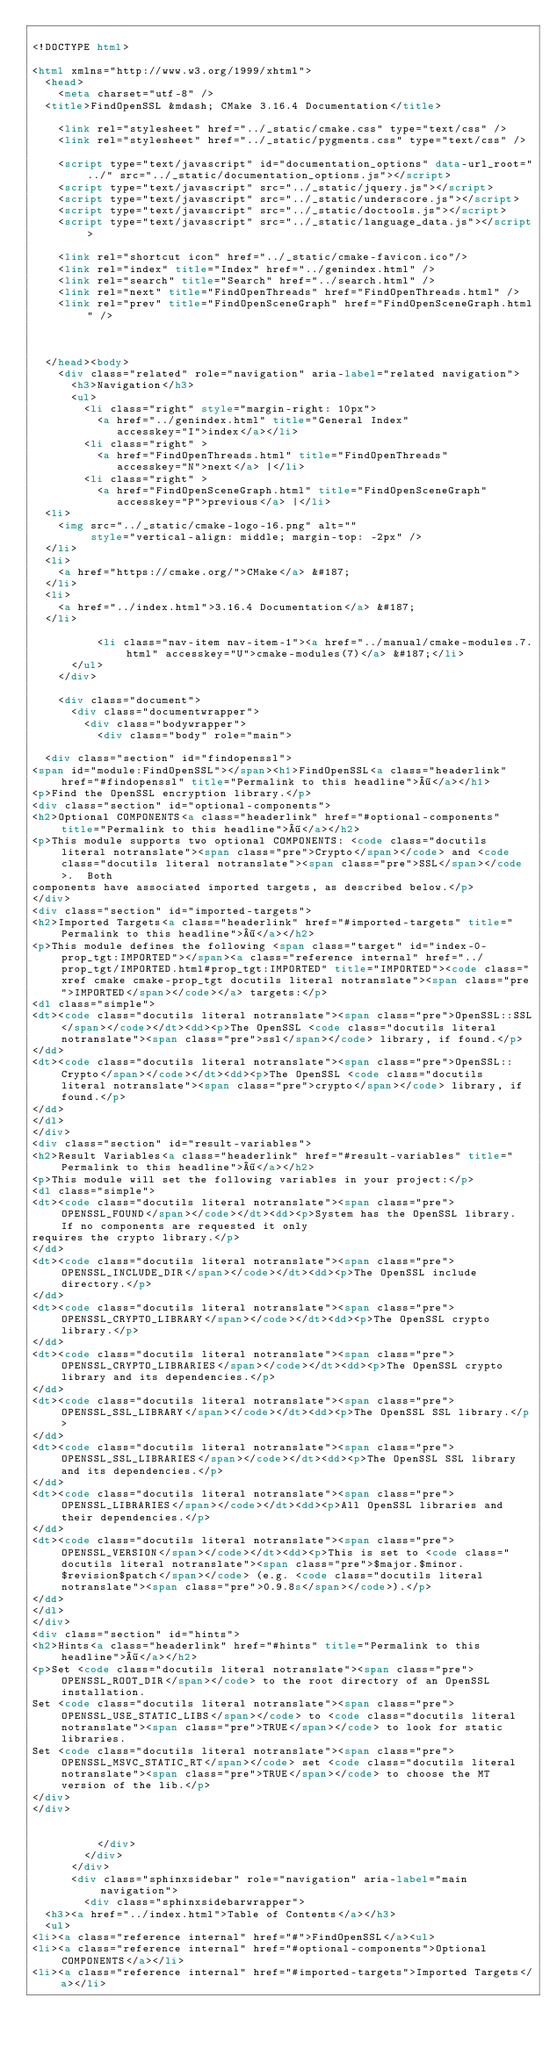Convert code to text. <code><loc_0><loc_0><loc_500><loc_500><_HTML_>
<!DOCTYPE html>

<html xmlns="http://www.w3.org/1999/xhtml">
  <head>
    <meta charset="utf-8" />
  <title>FindOpenSSL &mdash; CMake 3.16.4 Documentation</title>

    <link rel="stylesheet" href="../_static/cmake.css" type="text/css" />
    <link rel="stylesheet" href="../_static/pygments.css" type="text/css" />
    
    <script type="text/javascript" id="documentation_options" data-url_root="../" src="../_static/documentation_options.js"></script>
    <script type="text/javascript" src="../_static/jquery.js"></script>
    <script type="text/javascript" src="../_static/underscore.js"></script>
    <script type="text/javascript" src="../_static/doctools.js"></script>
    <script type="text/javascript" src="../_static/language_data.js"></script>
    
    <link rel="shortcut icon" href="../_static/cmake-favicon.ico"/>
    <link rel="index" title="Index" href="../genindex.html" />
    <link rel="search" title="Search" href="../search.html" />
    <link rel="next" title="FindOpenThreads" href="FindOpenThreads.html" />
    <link rel="prev" title="FindOpenSceneGraph" href="FindOpenSceneGraph.html" />
  
 

  </head><body>
    <div class="related" role="navigation" aria-label="related navigation">
      <h3>Navigation</h3>
      <ul>
        <li class="right" style="margin-right: 10px">
          <a href="../genindex.html" title="General Index"
             accesskey="I">index</a></li>
        <li class="right" >
          <a href="FindOpenThreads.html" title="FindOpenThreads"
             accesskey="N">next</a> |</li>
        <li class="right" >
          <a href="FindOpenSceneGraph.html" title="FindOpenSceneGraph"
             accesskey="P">previous</a> |</li>
  <li>
    <img src="../_static/cmake-logo-16.png" alt=""
         style="vertical-align: middle; margin-top: -2px" />
  </li>
  <li>
    <a href="https://cmake.org/">CMake</a> &#187;
  </li>
  <li>
    <a href="../index.html">3.16.4 Documentation</a> &#187;
  </li>

          <li class="nav-item nav-item-1"><a href="../manual/cmake-modules.7.html" accesskey="U">cmake-modules(7)</a> &#187;</li> 
      </ul>
    </div>  

    <div class="document">
      <div class="documentwrapper">
        <div class="bodywrapper">
          <div class="body" role="main">
            
  <div class="section" id="findopenssl">
<span id="module:FindOpenSSL"></span><h1>FindOpenSSL<a class="headerlink" href="#findopenssl" title="Permalink to this headline">¶</a></h1>
<p>Find the OpenSSL encryption library.</p>
<div class="section" id="optional-components">
<h2>Optional COMPONENTS<a class="headerlink" href="#optional-components" title="Permalink to this headline">¶</a></h2>
<p>This module supports two optional COMPONENTS: <code class="docutils literal notranslate"><span class="pre">Crypto</span></code> and <code class="docutils literal notranslate"><span class="pre">SSL</span></code>.  Both
components have associated imported targets, as described below.</p>
</div>
<div class="section" id="imported-targets">
<h2>Imported Targets<a class="headerlink" href="#imported-targets" title="Permalink to this headline">¶</a></h2>
<p>This module defines the following <span class="target" id="index-0-prop_tgt:IMPORTED"></span><a class="reference internal" href="../prop_tgt/IMPORTED.html#prop_tgt:IMPORTED" title="IMPORTED"><code class="xref cmake cmake-prop_tgt docutils literal notranslate"><span class="pre">IMPORTED</span></code></a> targets:</p>
<dl class="simple">
<dt><code class="docutils literal notranslate"><span class="pre">OpenSSL::SSL</span></code></dt><dd><p>The OpenSSL <code class="docutils literal notranslate"><span class="pre">ssl</span></code> library, if found.</p>
</dd>
<dt><code class="docutils literal notranslate"><span class="pre">OpenSSL::Crypto</span></code></dt><dd><p>The OpenSSL <code class="docutils literal notranslate"><span class="pre">crypto</span></code> library, if found.</p>
</dd>
</dl>
</div>
<div class="section" id="result-variables">
<h2>Result Variables<a class="headerlink" href="#result-variables" title="Permalink to this headline">¶</a></h2>
<p>This module will set the following variables in your project:</p>
<dl class="simple">
<dt><code class="docutils literal notranslate"><span class="pre">OPENSSL_FOUND</span></code></dt><dd><p>System has the OpenSSL library. If no components are requested it only
requires the crypto library.</p>
</dd>
<dt><code class="docutils literal notranslate"><span class="pre">OPENSSL_INCLUDE_DIR</span></code></dt><dd><p>The OpenSSL include directory.</p>
</dd>
<dt><code class="docutils literal notranslate"><span class="pre">OPENSSL_CRYPTO_LIBRARY</span></code></dt><dd><p>The OpenSSL crypto library.</p>
</dd>
<dt><code class="docutils literal notranslate"><span class="pre">OPENSSL_CRYPTO_LIBRARIES</span></code></dt><dd><p>The OpenSSL crypto library and its dependencies.</p>
</dd>
<dt><code class="docutils literal notranslate"><span class="pre">OPENSSL_SSL_LIBRARY</span></code></dt><dd><p>The OpenSSL SSL library.</p>
</dd>
<dt><code class="docutils literal notranslate"><span class="pre">OPENSSL_SSL_LIBRARIES</span></code></dt><dd><p>The OpenSSL SSL library and its dependencies.</p>
</dd>
<dt><code class="docutils literal notranslate"><span class="pre">OPENSSL_LIBRARIES</span></code></dt><dd><p>All OpenSSL libraries and their dependencies.</p>
</dd>
<dt><code class="docutils literal notranslate"><span class="pre">OPENSSL_VERSION</span></code></dt><dd><p>This is set to <code class="docutils literal notranslate"><span class="pre">$major.$minor.$revision$patch</span></code> (e.g. <code class="docutils literal notranslate"><span class="pre">0.9.8s</span></code>).</p>
</dd>
</dl>
</div>
<div class="section" id="hints">
<h2>Hints<a class="headerlink" href="#hints" title="Permalink to this headline">¶</a></h2>
<p>Set <code class="docutils literal notranslate"><span class="pre">OPENSSL_ROOT_DIR</span></code> to the root directory of an OpenSSL installation.
Set <code class="docutils literal notranslate"><span class="pre">OPENSSL_USE_STATIC_LIBS</span></code> to <code class="docutils literal notranslate"><span class="pre">TRUE</span></code> to look for static libraries.
Set <code class="docutils literal notranslate"><span class="pre">OPENSSL_MSVC_STATIC_RT</span></code> set <code class="docutils literal notranslate"><span class="pre">TRUE</span></code> to choose the MT version of the lib.</p>
</div>
</div>


          </div>
        </div>
      </div>
      <div class="sphinxsidebar" role="navigation" aria-label="main navigation">
        <div class="sphinxsidebarwrapper">
  <h3><a href="../index.html">Table of Contents</a></h3>
  <ul>
<li><a class="reference internal" href="#">FindOpenSSL</a><ul>
<li><a class="reference internal" href="#optional-components">Optional COMPONENTS</a></li>
<li><a class="reference internal" href="#imported-targets">Imported Targets</a></li></code> 